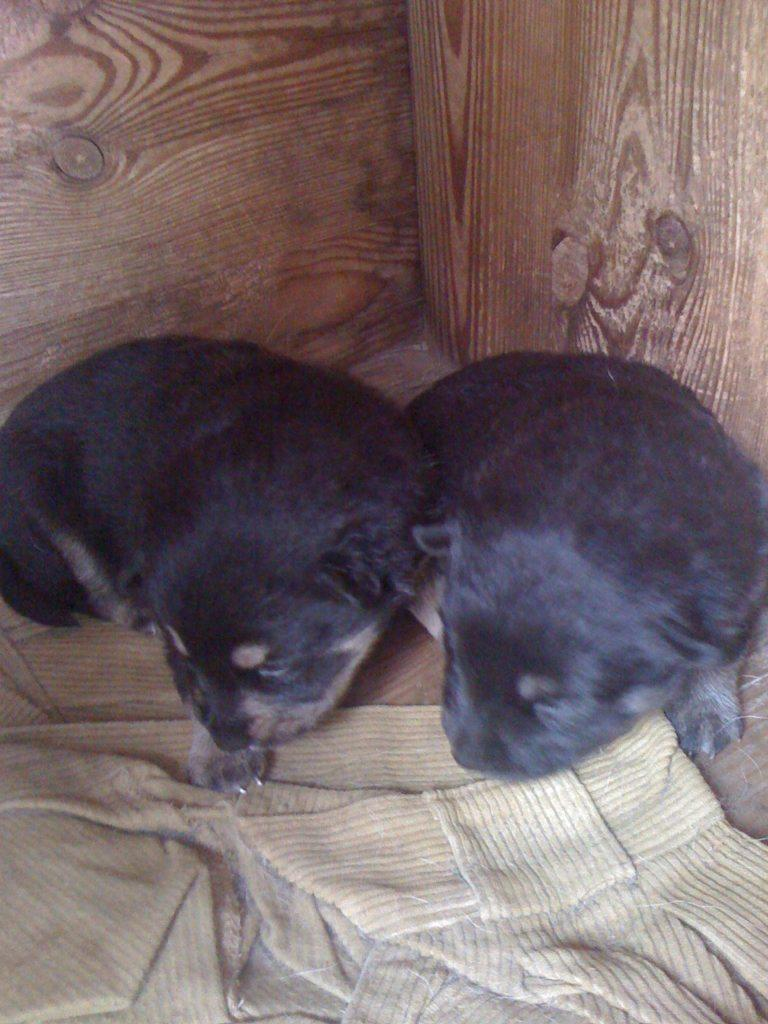What types of living organisms are in the image? There are two animals in the image. What is the cloth placed on in the image? The cloth is on a wooden surface. What can be seen in the background of the image? The background of the image includes walls. What innovative idea is being discussed by the animals in the image? There is no indication in the image that the animals are discussing any ideas, as they are not depicted as engaging in conversation or any other activity that would suggest the presence of an idea. 